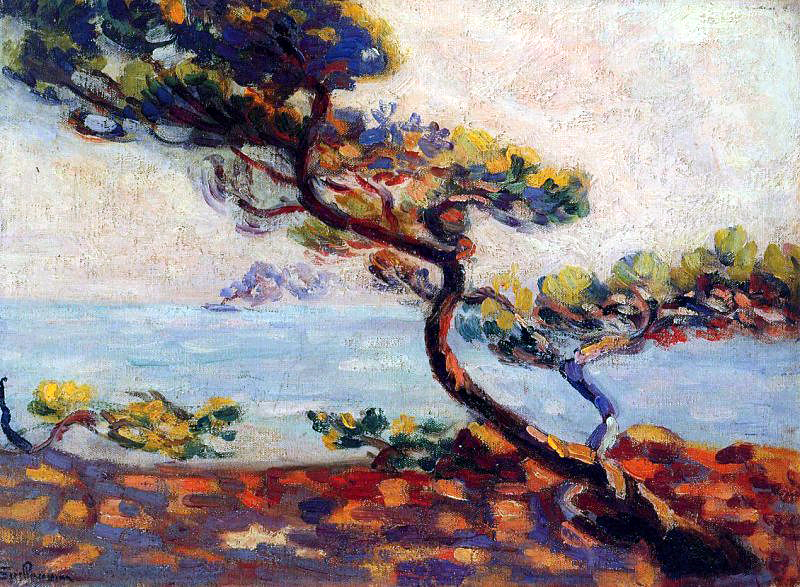Imagine the painting is part of a larger narrative. What could the story be? In a quiet coastal village on the French Riviera, an old, twisted tree stands as a silent witness to the passage of time. It has seen generations of villagers grow up, fishermen set sail at dawn, and lovers walking hand in hand along the rocky shore. The tree symbolizes endurance and resilience, having weathered countless storms while continuing to thrive in its solitary splendor. In a more recent chapter of its enduring story, a young artist discovers the tree and, inspired by its serene yet powerful presence, creates a series of paintings that capture the heart and soul of the region. 